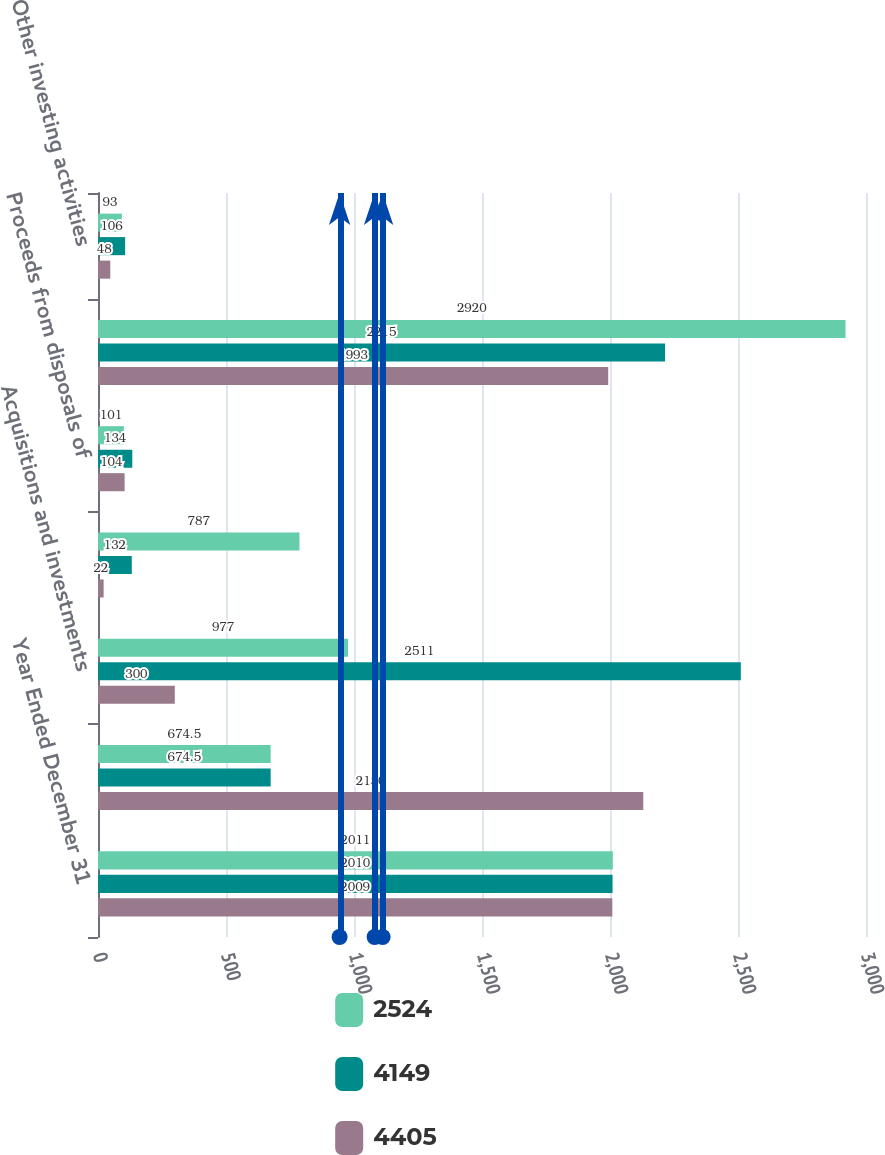<chart> <loc_0><loc_0><loc_500><loc_500><stacked_bar_chart><ecel><fcel>Year Ended December 31<fcel>Purchases of short-term<fcel>Acquisitions and investments<fcel>Purchases of other investments<fcel>Proceeds from disposals of<fcel>Purchases of property plant<fcel>Other investing activities<nl><fcel>2524<fcel>2011<fcel>674.5<fcel>977<fcel>787<fcel>101<fcel>2920<fcel>93<nl><fcel>4149<fcel>2010<fcel>674.5<fcel>2511<fcel>132<fcel>134<fcel>2215<fcel>106<nl><fcel>4405<fcel>2009<fcel>2130<fcel>300<fcel>22<fcel>104<fcel>1993<fcel>48<nl></chart> 